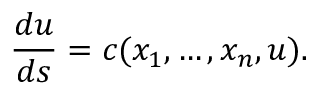<formula> <loc_0><loc_0><loc_500><loc_500>{ \frac { d u } { d s } } = c ( x _ { 1 } , \dots , x _ { n } , u ) .</formula> 